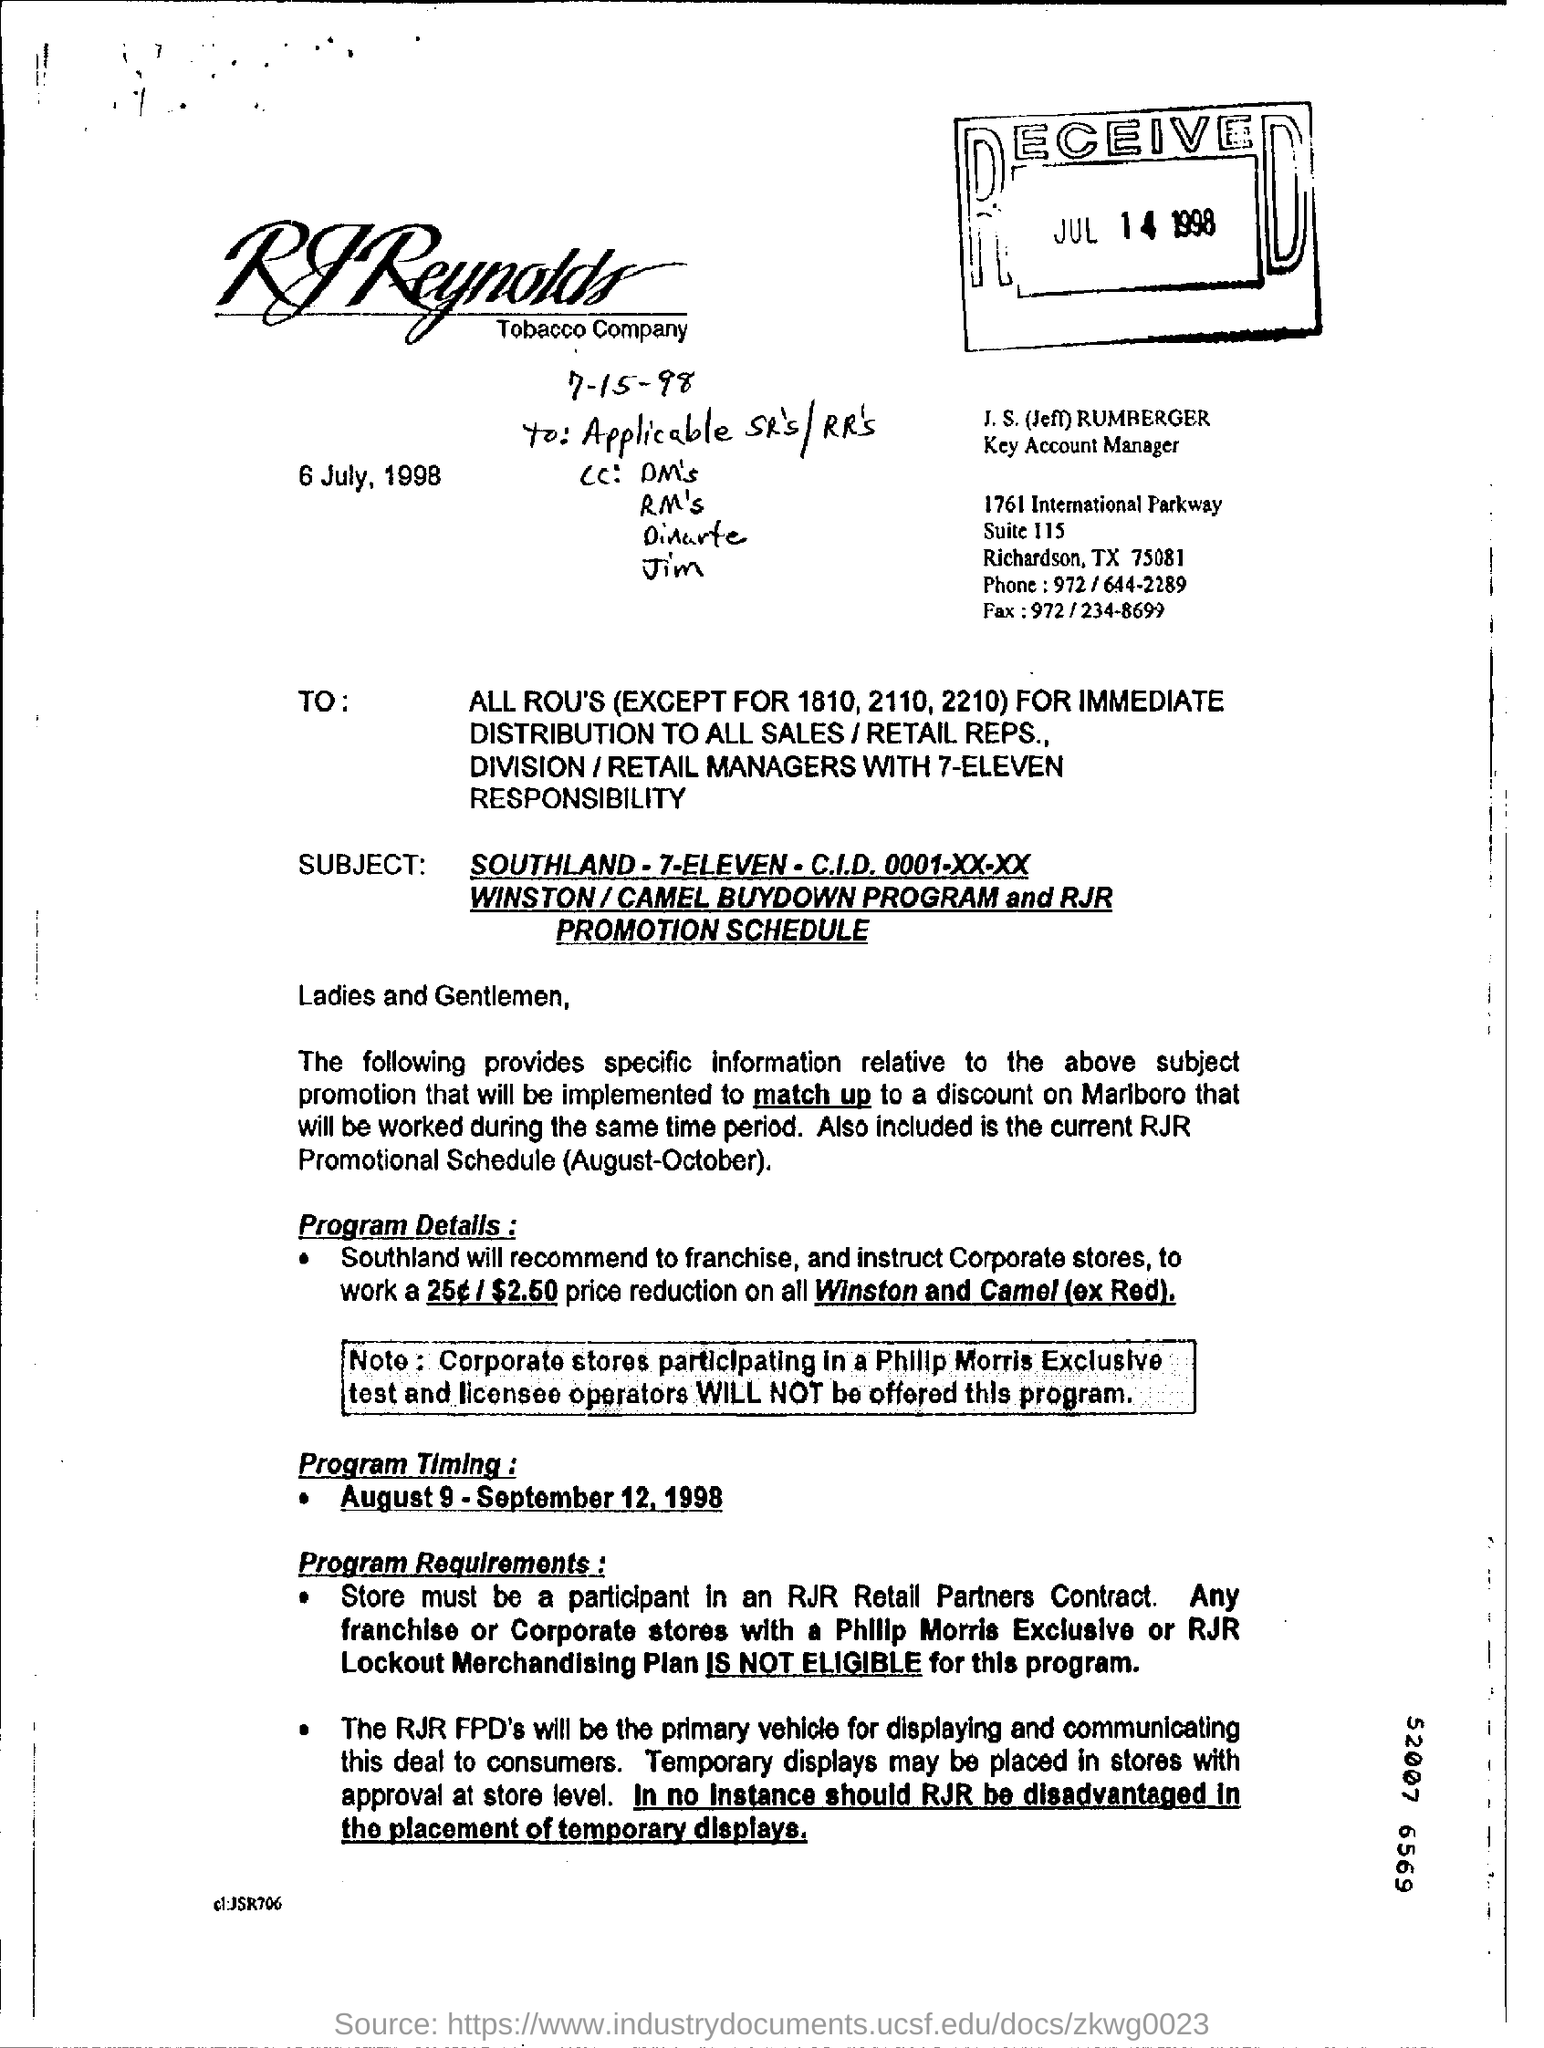What is the date mentioned?
Ensure brevity in your answer.  6 july , 1998. What is the designation of J. S. (Jeff) RUMBERGER?
Make the answer very short. Key Account Manager. What is the 9 digits number mentioned?
Offer a very short reply. 52007 6569. 